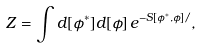Convert formula to latex. <formula><loc_0><loc_0><loc_500><loc_500>Z = \int d [ \phi ^ { * } ] d [ \phi ] \, e ^ { - S [ \phi ^ { * } , \phi ] / } ,</formula> 